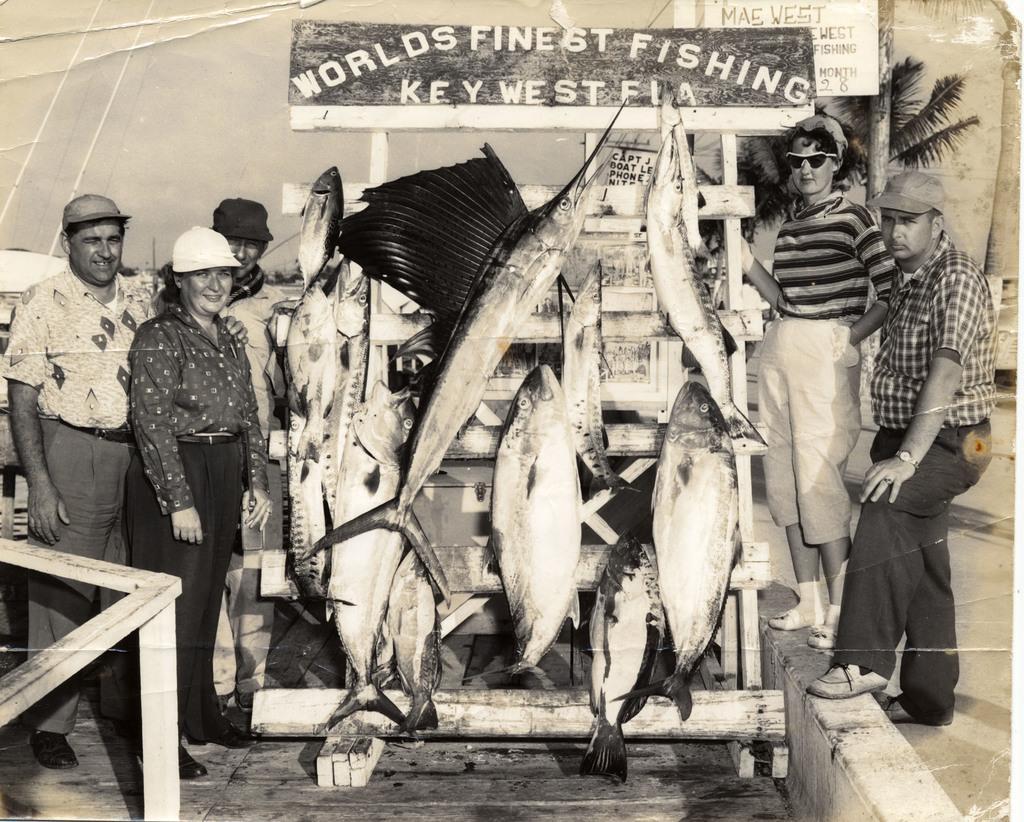Please provide a concise description of this image. This is a black and white image. In this image we can see some fishes kept on a stand. We can also see a group of people standing around it. On the backside we can see a board with some text on it, trees and the sky. 